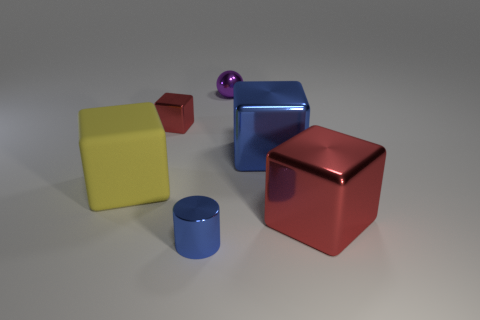Subtract 1 cubes. How many cubes are left? 3 Add 3 tiny cyan matte cylinders. How many objects exist? 9 Subtract all cylinders. How many objects are left? 5 Add 2 cylinders. How many cylinders exist? 3 Subtract 1 red cubes. How many objects are left? 5 Subtract all brown rubber balls. Subtract all red shiny cubes. How many objects are left? 4 Add 5 metallic cylinders. How many metallic cylinders are left? 6 